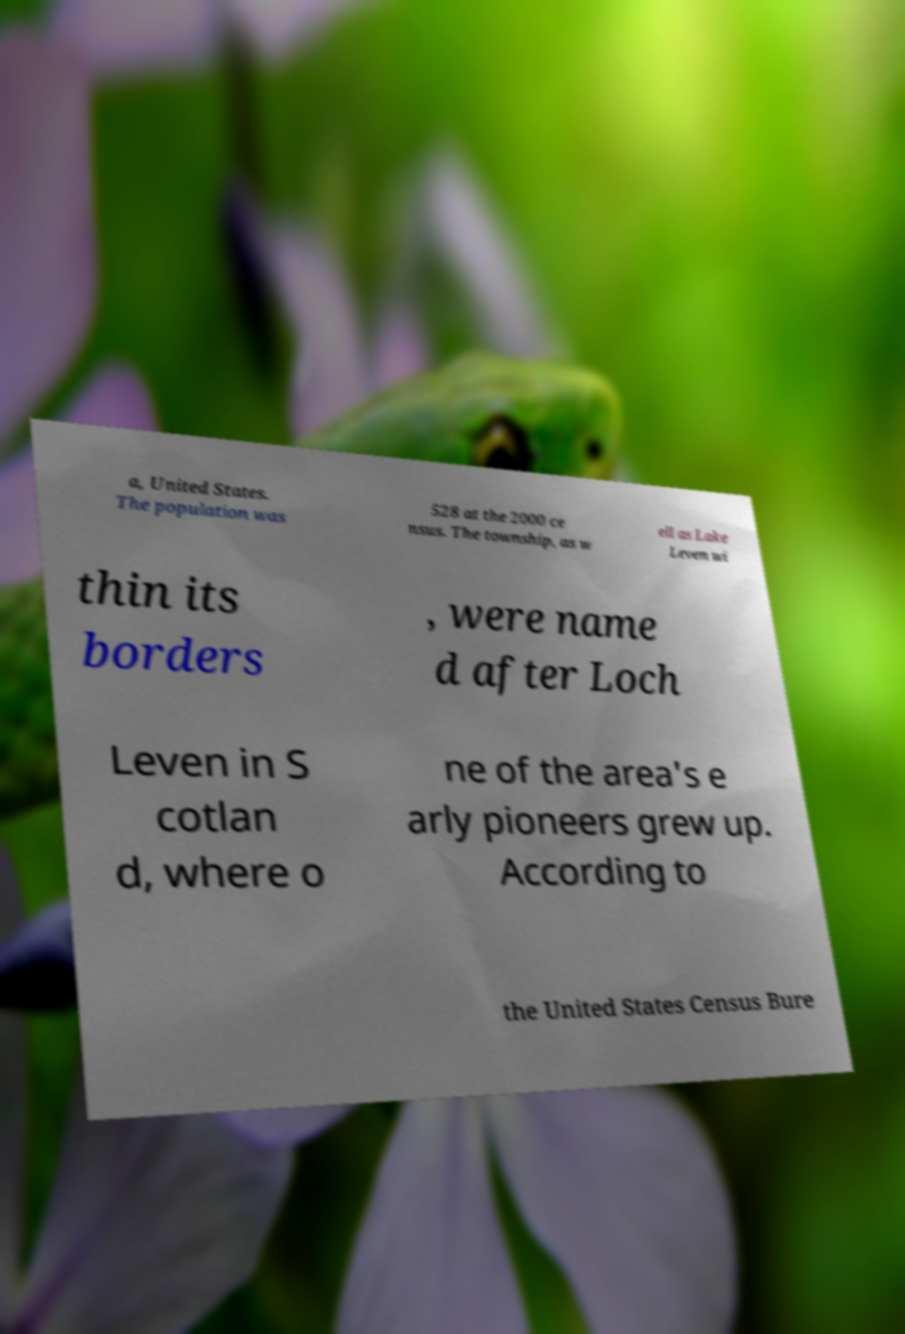There's text embedded in this image that I need extracted. Can you transcribe it verbatim? a, United States. The population was 528 at the 2000 ce nsus. The township, as w ell as Lake Leven wi thin its borders , were name d after Loch Leven in S cotlan d, where o ne of the area's e arly pioneers grew up. According to the United States Census Bure 